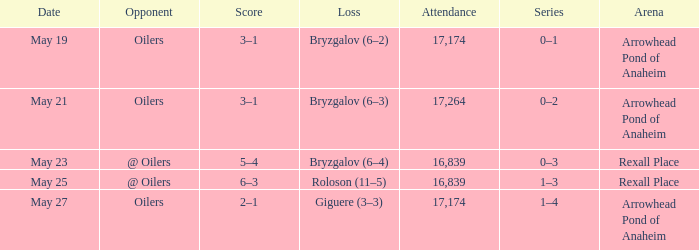Which Attendance has an Arena of arrowhead pond of anaheim, and a Loss of giguere (3–3)? 17174.0. 